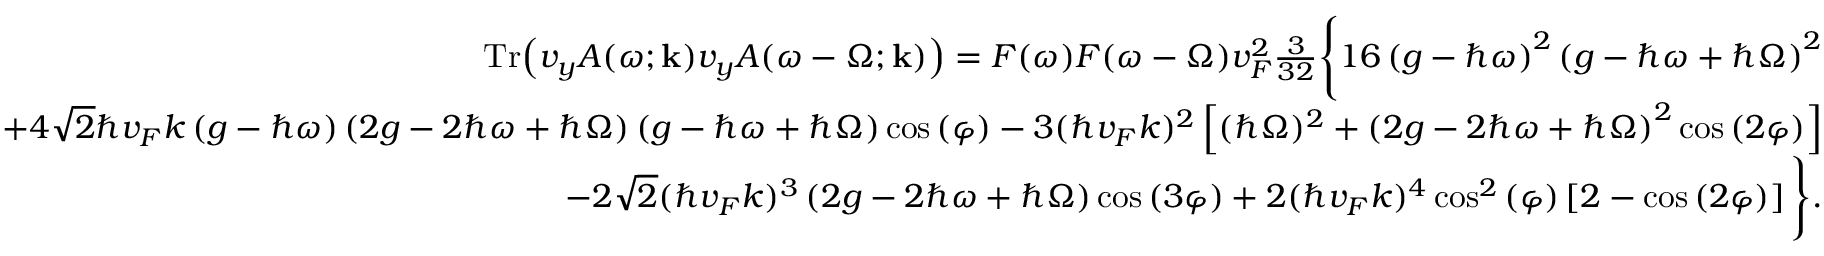<formula> <loc_0><loc_0><loc_500><loc_500>\begin{array} { r l r } & { T r { \left ( v _ { y } A ( \omega ; k ) v _ { y } A ( \omega - \Omega ; k ) \right ) } = F ( \omega ) F ( \omega - \Omega ) v _ { F } ^ { 2 } \frac { 3 } { 3 2 } \left \{ 1 6 \left ( g - \hbar { \omega } \right ) ^ { 2 } \left ( g - \hbar { \omega } + \hbar { \Omega } \right ) ^ { 2 } } \\ & { + 4 \sqrt { 2 } \hbar { v } _ { F } k \left ( g - \hbar { \omega } \right ) \left ( 2 g - 2 \hbar { \omega } + \hbar { \Omega } \right ) \left ( g - \hbar { \omega } + \hbar { \Omega } \right ) \cos { ( \varphi ) } - 3 ( \hbar { v } _ { F } k ) ^ { 2 } \left [ ( \hbar { \Omega } ) ^ { 2 } + \left ( 2 g - 2 \hbar { \omega } + \hbar { \Omega } \right ) ^ { 2 } \cos { ( 2 \varphi ) } \right ] } \\ & { - 2 \sqrt { 2 } ( \hbar { v } _ { F } k ) ^ { 3 } \left ( 2 g - 2 \hbar { \omega } + \hbar { \Omega } \right ) \cos { ( 3 \varphi ) } + 2 ( \hbar { v } _ { F } k ) ^ { 4 } \cos ^ { 2 } { ( \varphi ) } \left [ 2 - \cos { ( 2 \varphi ) } \right ] \right \} . } \end{array}</formula> 